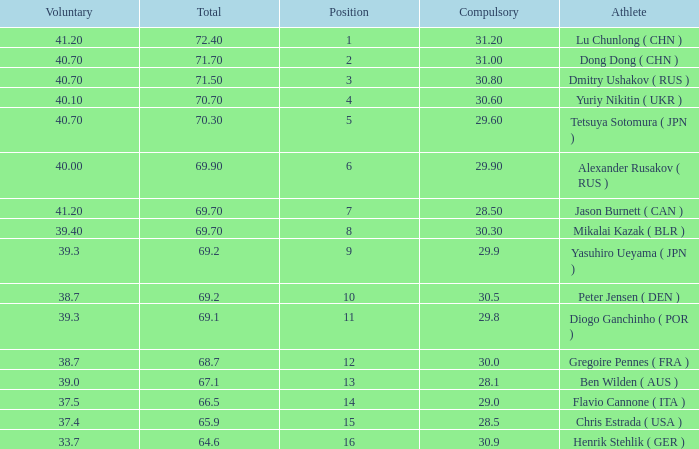What's the total of the position of 1? None. 